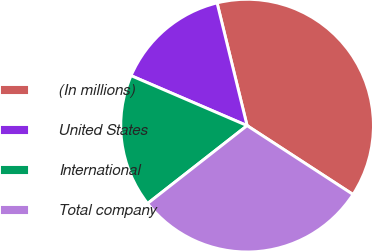<chart> <loc_0><loc_0><loc_500><loc_500><pie_chart><fcel>(In millions)<fcel>United States<fcel>International<fcel>Total company<nl><fcel>37.99%<fcel>14.71%<fcel>17.04%<fcel>30.26%<nl></chart> 